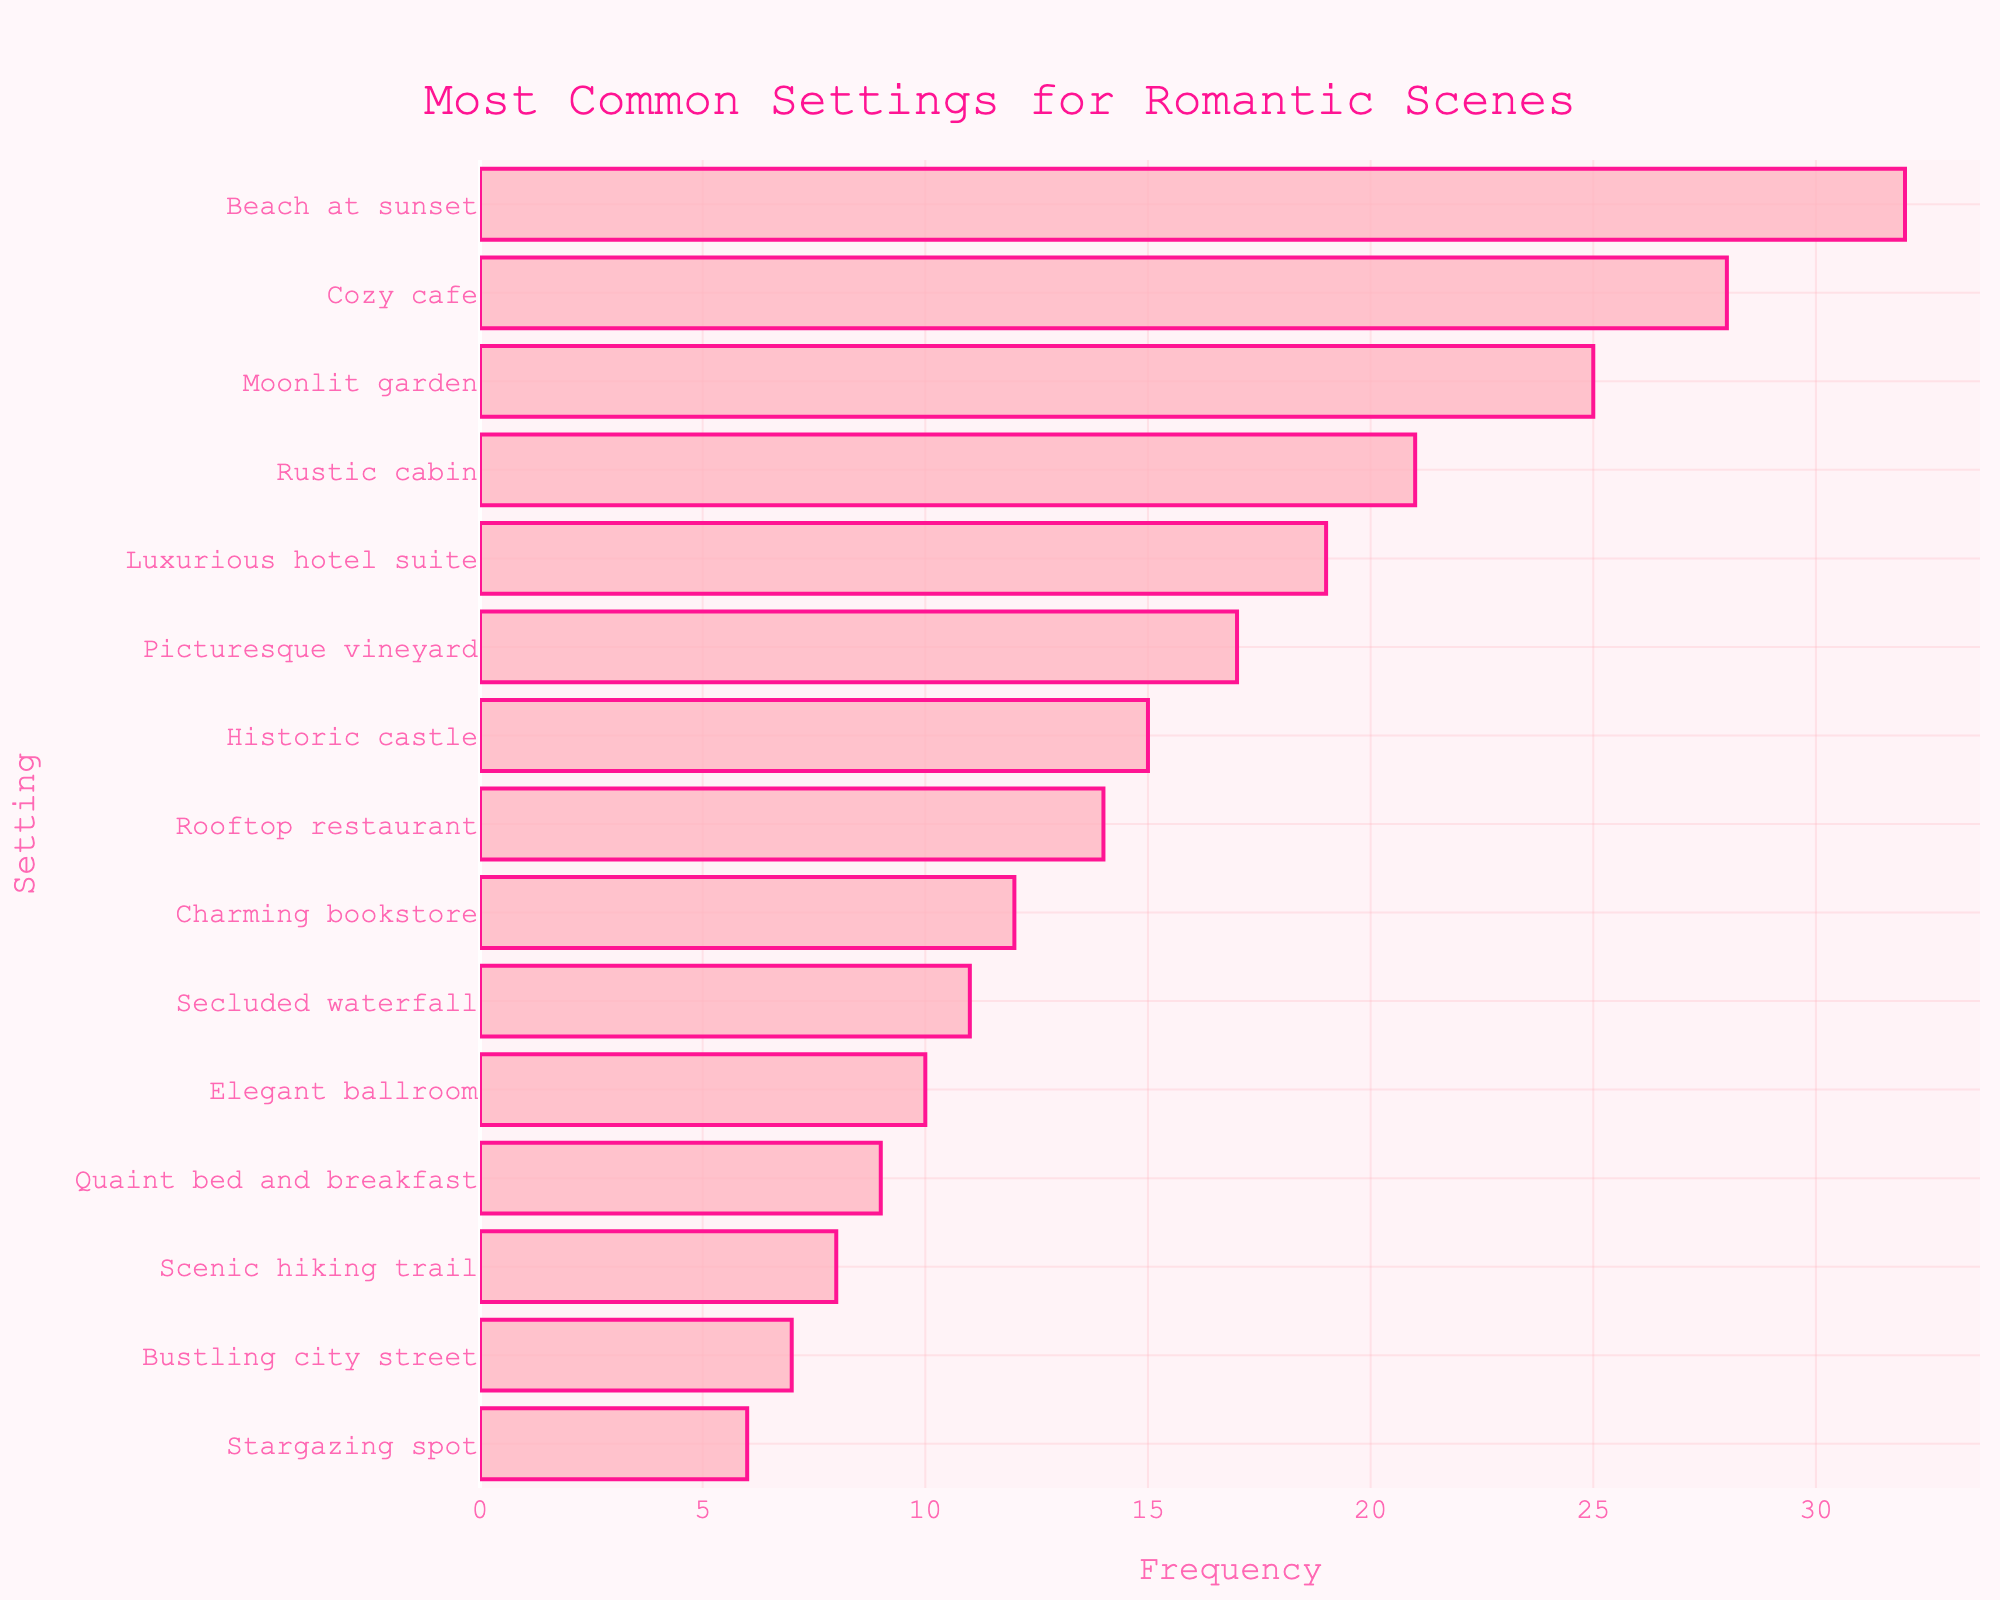What's the most common setting for romantic scenes? The most common setting is the one with the highest bar, which indicates the highest frequency. The Beach at sunset setting has the highest frequency of 32.
Answer: Beach at sunset Which setting has the second-highest frequency? The setting with the second-highest frequency is the one with the second-tallest bar. The Cozy cafe setting has the second-highest frequency of 28.
Answer: Cozy cafe How many more romantic scenes are set in a Beach at sunset compared to a Moonlit garden? Subtract the frequency of the Moonlit garden setting from the frequency of the Beach at sunset setting: 32 - 25 = 7.
Answer: 7 What is the combined frequency of romantic scenes set in a Beach at sunset, a Cozy cafe, and a Rooftop restaurant? Add the frequencies of these three settings: Beach at sunset (32) + Cozy cafe (28) + Rooftop restaurant (14) = 74.
Answer: 74 Which settings have a frequency greater than 20? Identify the settings with bars longer than 20 units on the x-axis: Beach at sunset (32), Cozy cafe (28), Moonlit garden (25), and Rustic cabin (21).
Answer: Beach at sunset, Cozy cafe, Moonlit garden, Rustic cabin Is the frequency of romantic scenes in a Luxurious hotel suite higher or lower than in a Picturesque vineyard? Compare the heights (lengths) of bars for these two settings: Luxurious hotel suite (19) is higher than Picturesque vineyard (17).
Answer: Higher What is the total frequency of the three least common settings for romantic scenes? Add the frequencies of the three settings with the shortest bars: Bustling city street (7) + Stargazing spot (6) + Secluded waterfall (11) = 24.
Answer: 24 Which setting has the lowest frequency of romantic scenes, and what is its frequency? The setting with the smallest bar (shortest length) has the lowest frequency: Stargazing spot with a frequency of 6.
Answer: Stargazing spot, 6 Is there a higher frequency of romantic scenes in a Historic castle or a Quaint bed and breakfast? Compare the bar heights of these two settings: Historic castle (15) is higher than Quaint bed and breakfast (9).
Answer: Historic castle 